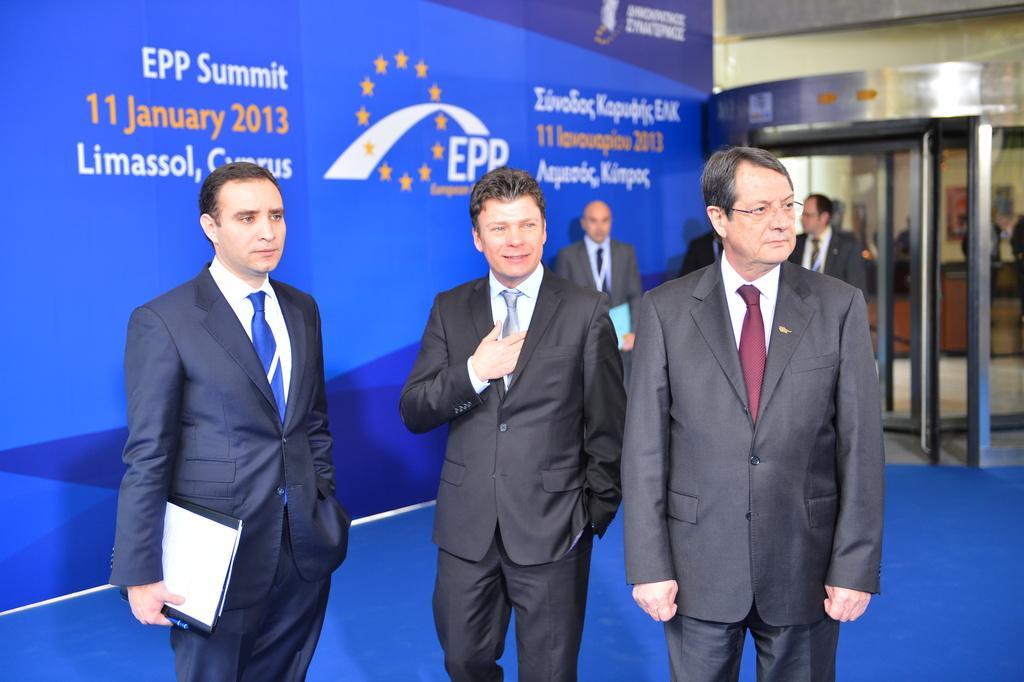Can you describe this image briefly? This picture describes about group of people, few people holding files, in the background we can see a hoarding. 